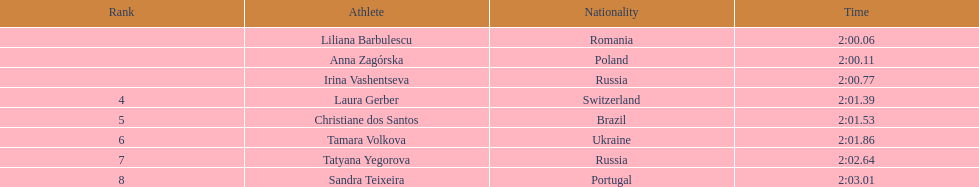For the 2nd place finisher, anna zagorska, what was her time? 2:00.11. 